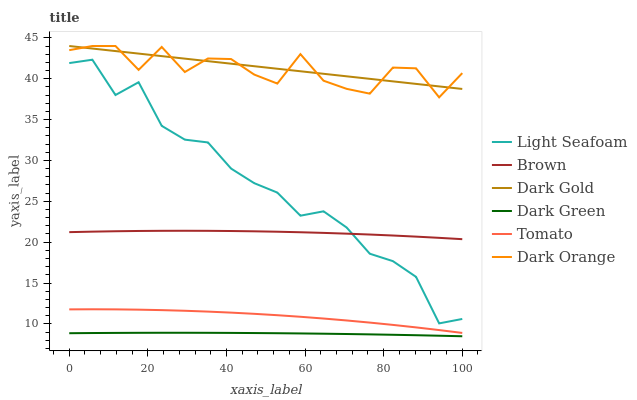Does Dark Green have the minimum area under the curve?
Answer yes or no. Yes. Does Dark Gold have the maximum area under the curve?
Answer yes or no. Yes. Does Brown have the minimum area under the curve?
Answer yes or no. No. Does Brown have the maximum area under the curve?
Answer yes or no. No. Is Dark Gold the smoothest?
Answer yes or no. Yes. Is Dark Orange the roughest?
Answer yes or no. Yes. Is Brown the smoothest?
Answer yes or no. No. Is Brown the roughest?
Answer yes or no. No. Does Dark Green have the lowest value?
Answer yes or no. Yes. Does Brown have the lowest value?
Answer yes or no. No. Does Dark Gold have the highest value?
Answer yes or no. Yes. Does Brown have the highest value?
Answer yes or no. No. Is Tomato less than Light Seafoam?
Answer yes or no. Yes. Is Dark Orange greater than Light Seafoam?
Answer yes or no. Yes. Does Dark Orange intersect Dark Gold?
Answer yes or no. Yes. Is Dark Orange less than Dark Gold?
Answer yes or no. No. Is Dark Orange greater than Dark Gold?
Answer yes or no. No. Does Tomato intersect Light Seafoam?
Answer yes or no. No. 